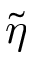Convert formula to latex. <formula><loc_0><loc_0><loc_500><loc_500>\tilde { \eta }</formula> 